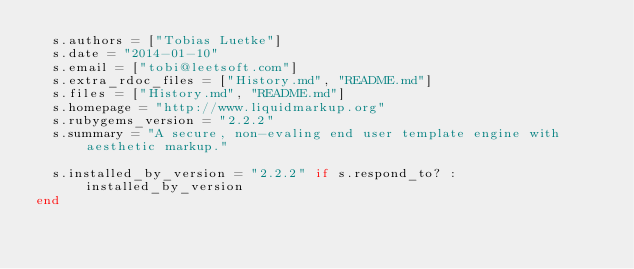Convert code to text. <code><loc_0><loc_0><loc_500><loc_500><_Ruby_>  s.authors = ["Tobias Luetke"]
  s.date = "2014-01-10"
  s.email = ["tobi@leetsoft.com"]
  s.extra_rdoc_files = ["History.md", "README.md"]
  s.files = ["History.md", "README.md"]
  s.homepage = "http://www.liquidmarkup.org"
  s.rubygems_version = "2.2.2"
  s.summary = "A secure, non-evaling end user template engine with aesthetic markup."

  s.installed_by_version = "2.2.2" if s.respond_to? :installed_by_version
end
</code> 